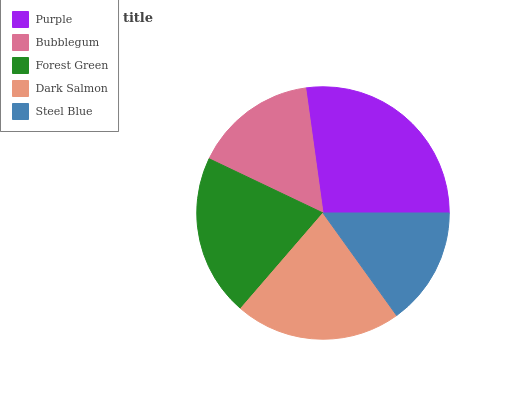Is Steel Blue the minimum?
Answer yes or no. Yes. Is Purple the maximum?
Answer yes or no. Yes. Is Bubblegum the minimum?
Answer yes or no. No. Is Bubblegum the maximum?
Answer yes or no. No. Is Purple greater than Bubblegum?
Answer yes or no. Yes. Is Bubblegum less than Purple?
Answer yes or no. Yes. Is Bubblegum greater than Purple?
Answer yes or no. No. Is Purple less than Bubblegum?
Answer yes or no. No. Is Forest Green the high median?
Answer yes or no. Yes. Is Forest Green the low median?
Answer yes or no. Yes. Is Purple the high median?
Answer yes or no. No. Is Purple the low median?
Answer yes or no. No. 